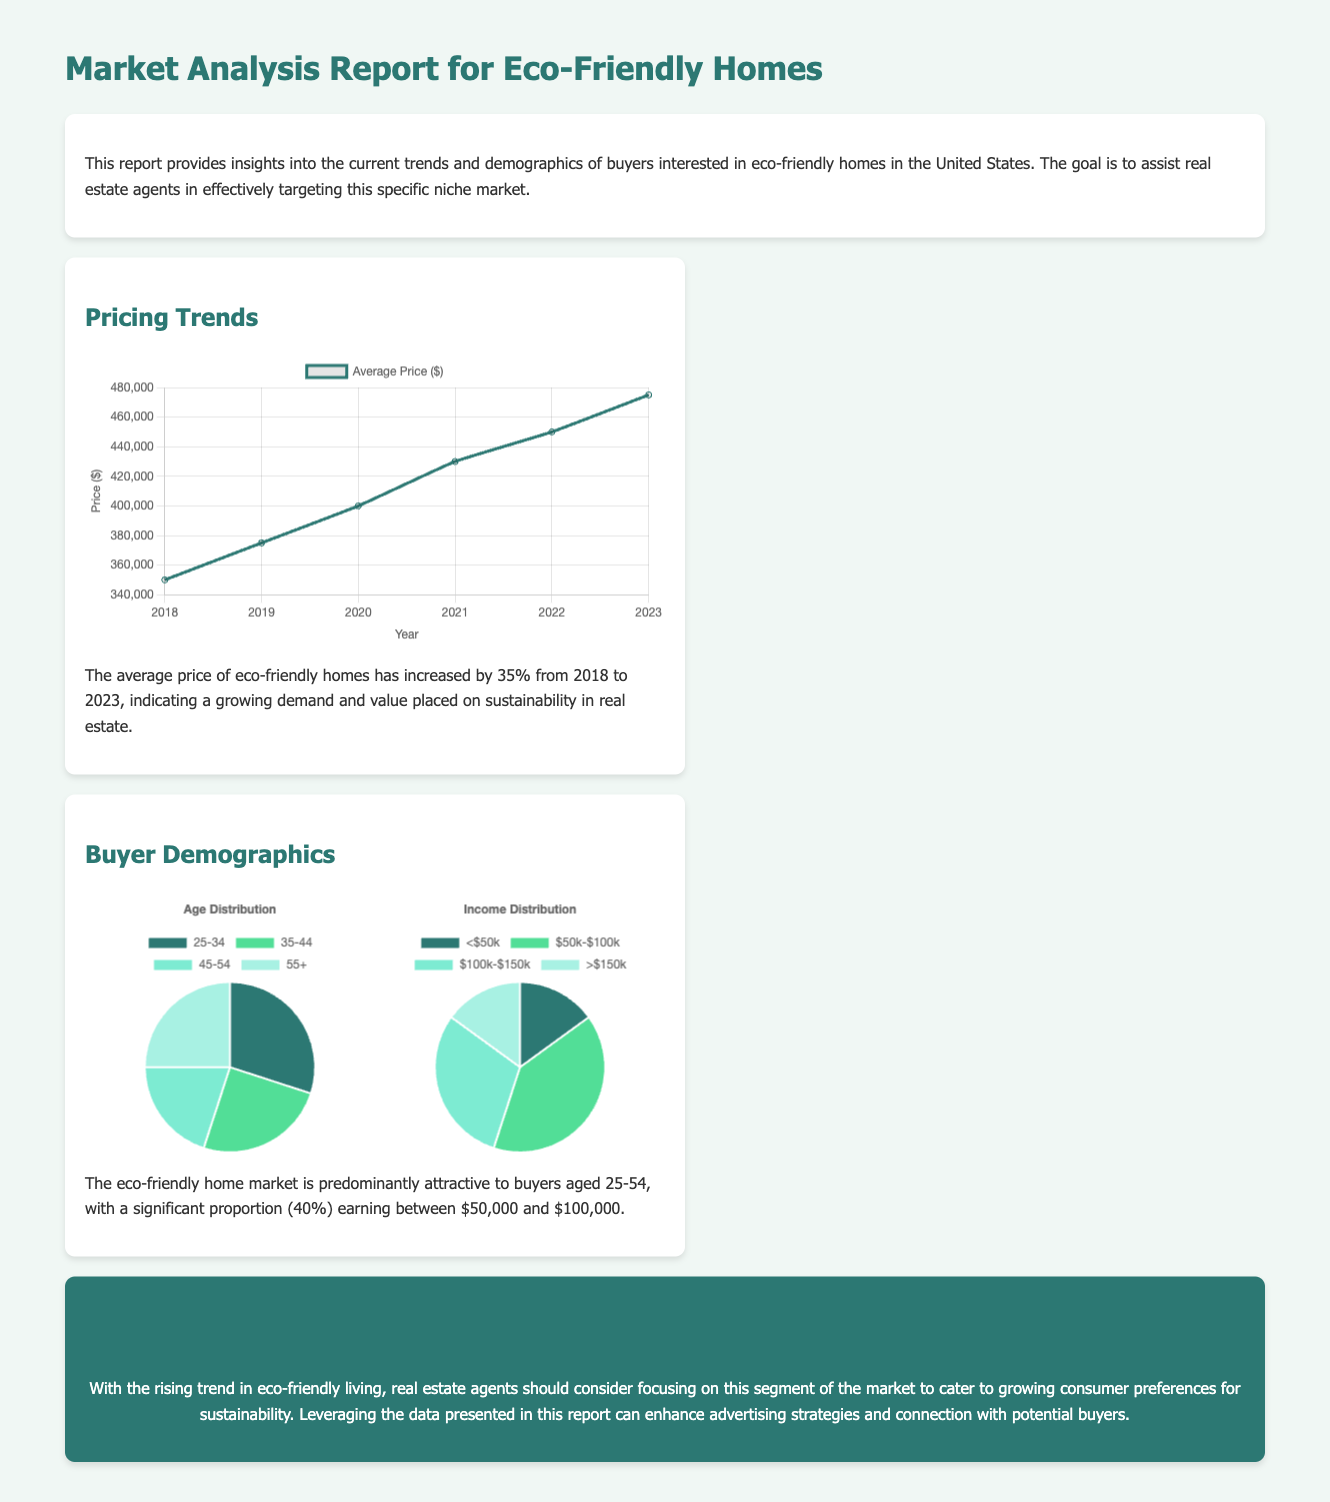What is the average price of eco-friendly homes in 2023? The average price of eco-friendly homes has increased to $475,000 in 2023.
Answer: $475,000 What percentage of buyers earn between $50,000 and $100,000? The document states that a significant proportion (40%) of buyers earn between $50,000 and $100,000.
Answer: 40% By how much has the average price of eco-friendly homes increased since 2018? The average price has increased by 35% from 2018 to 2023.
Answer: 35% What age group is most attracted to eco-friendly homes? The dominant age group attracted to eco-friendly homes is aged 25-54.
Answer: 25-54 How many segments are shown in the age distribution chart? The age distribution chart has four segments representing different age brackets.
Answer: Four segments What color represents the income group earning between $50,000 and $100,000 in the income chart? The income group earning between $50,000 and $100,000 is represented by the color green.
Answer: Green What is the report's primary focus? The report primarily focuses on the market trends and demographics of eco-friendly home buyers.
Answer: Eco-friendly home buyers Which year shows the lowest average price among the reported years? The year 2018 shows the lowest average price at $350,000.
Answer: 2018 